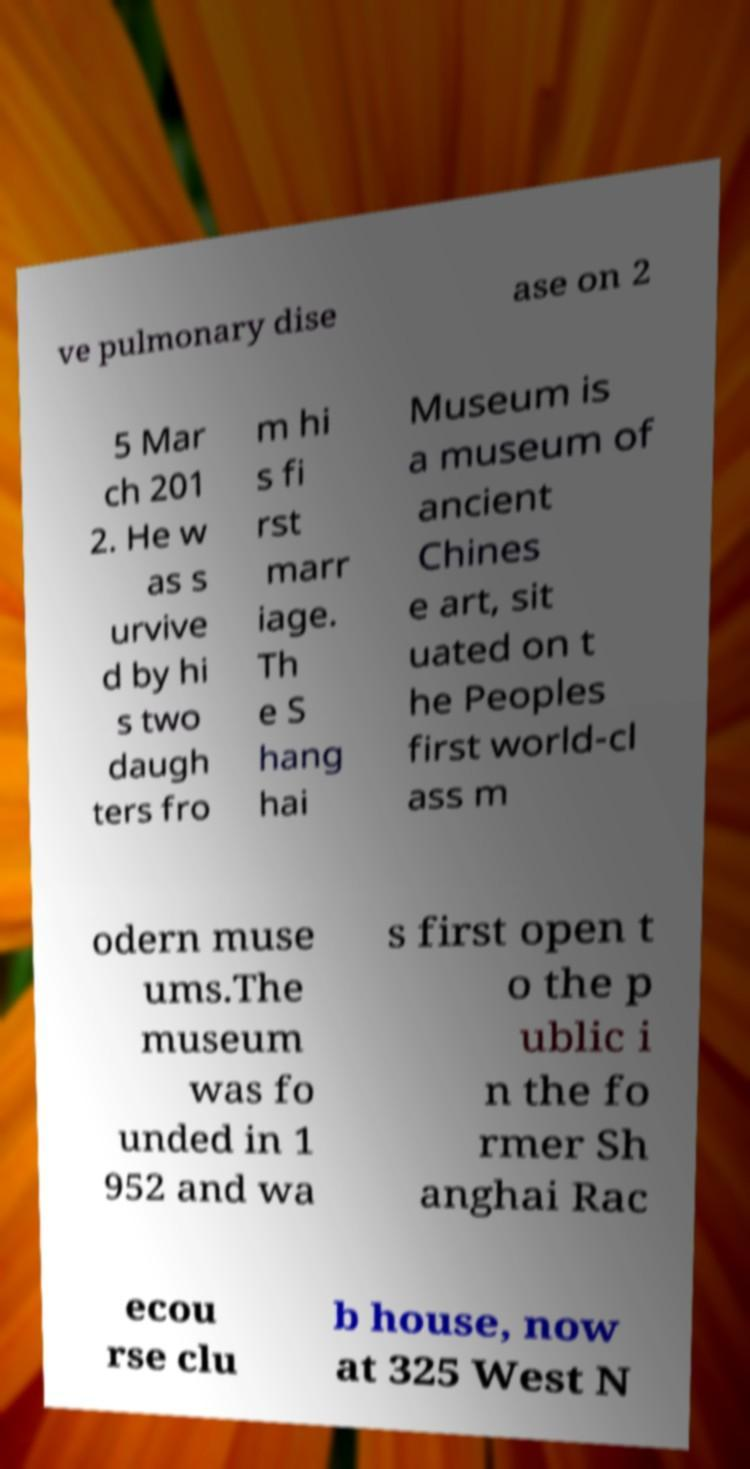There's text embedded in this image that I need extracted. Can you transcribe it verbatim? ve pulmonary dise ase on 2 5 Mar ch 201 2. He w as s urvive d by hi s two daugh ters fro m hi s fi rst marr iage. Th e S hang hai Museum is a museum of ancient Chines e art, sit uated on t he Peoples first world-cl ass m odern muse ums.The museum was fo unded in 1 952 and wa s first open t o the p ublic i n the fo rmer Sh anghai Rac ecou rse clu b house, now at 325 West N 